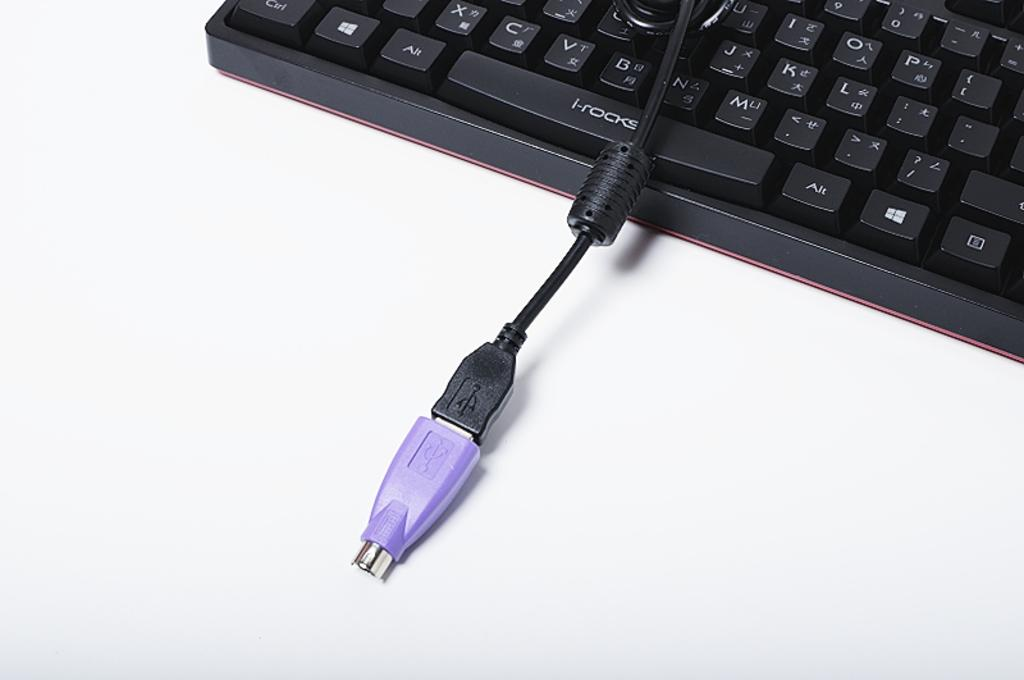<image>
Render a clear and concise summary of the photo. Purple USB cord on top of a keyboard that has i-rocks on the space bar. 